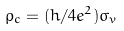<formula> <loc_0><loc_0><loc_500><loc_500>\rho _ { c } = ( h / 4 e ^ { 2 } ) \sigma _ { v }</formula> 